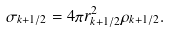Convert formula to latex. <formula><loc_0><loc_0><loc_500><loc_500>\sigma _ { k + 1 / 2 } = 4 \pi r ^ { 2 } _ { k + 1 / 2 } \rho _ { k + 1 / 2 } .</formula> 